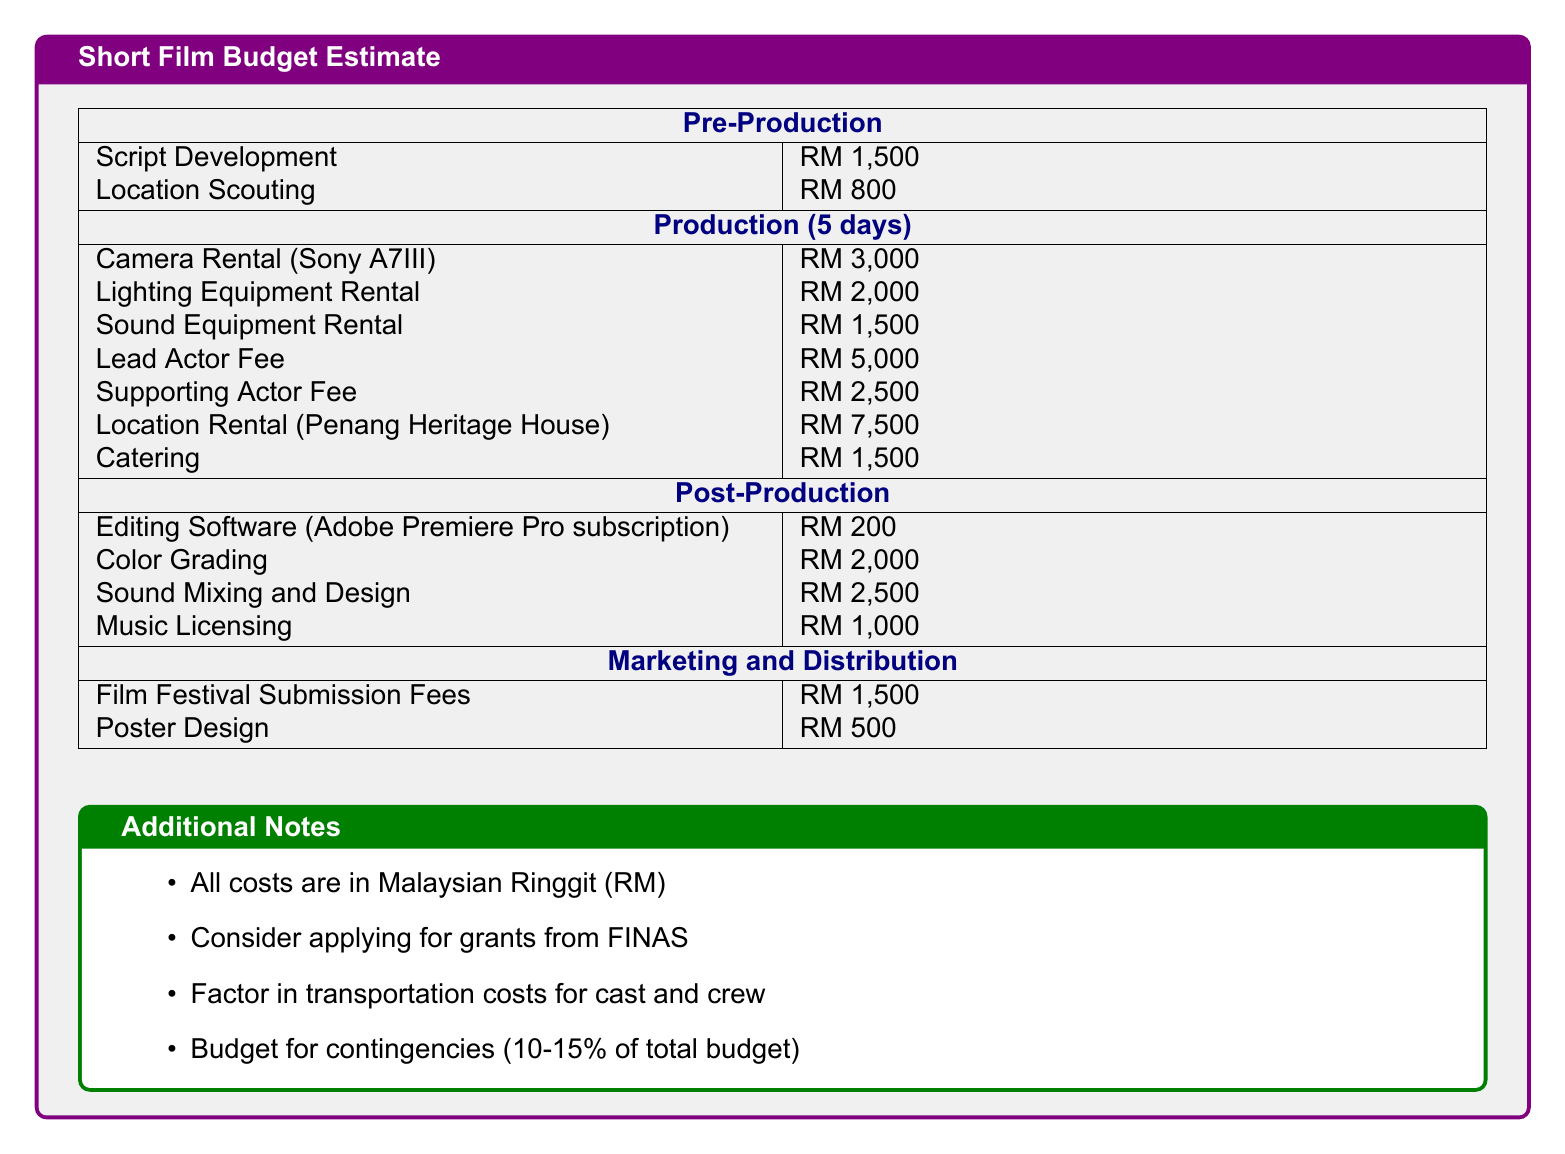What is the total cost for production? The total cost for production can be calculated by summing all production costs listed: RM 3,000 + RM 2,000 + RM 1,500 + RM 5,000 + RM 2,500 + RM 7,500 + RM 1,500 = RM 23,000.
Answer: RM 23,000 How much is the lead actor fee? The lead actor fee is specified as RM 5,000 in the document.
Answer: RM 5,000 What is the cost of sound mixing and design? The cost of sound mixing and design is directly stated in the document as RM 2,500.
Answer: RM 2,500 What type of equipment is rented for RM 3,000? The equipment rented for RM 3,000 is the camera, specifically the Sony A7III.
Answer: Camera (Sony A7III) What are the total post-production costs? The total post-production costs can be calculated by adding all post-production expenses: RM 200 + RM 2,000 + RM 2,500 + RM 1,000 = RM 5,700.
Answer: RM 5,700 What percentage should be budgeted for contingencies? The document states that 10-15% of the total budget should be budgeted for contingencies.
Answer: 10-15% What is the total estimated budget for marketing and distribution? The total estimated budget can be calculated by summing film festival submission fees and poster design: RM 1,500 + RM 500 = RM 2,000.
Answer: RM 2,000 How much does it cost to rent the location? The cost to rent the Penang Heritage House is specified as RM 7,500 in the document.
Answer: RM 7,500 